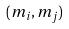<formula> <loc_0><loc_0><loc_500><loc_500>( m _ { i } , m _ { j } )</formula> 